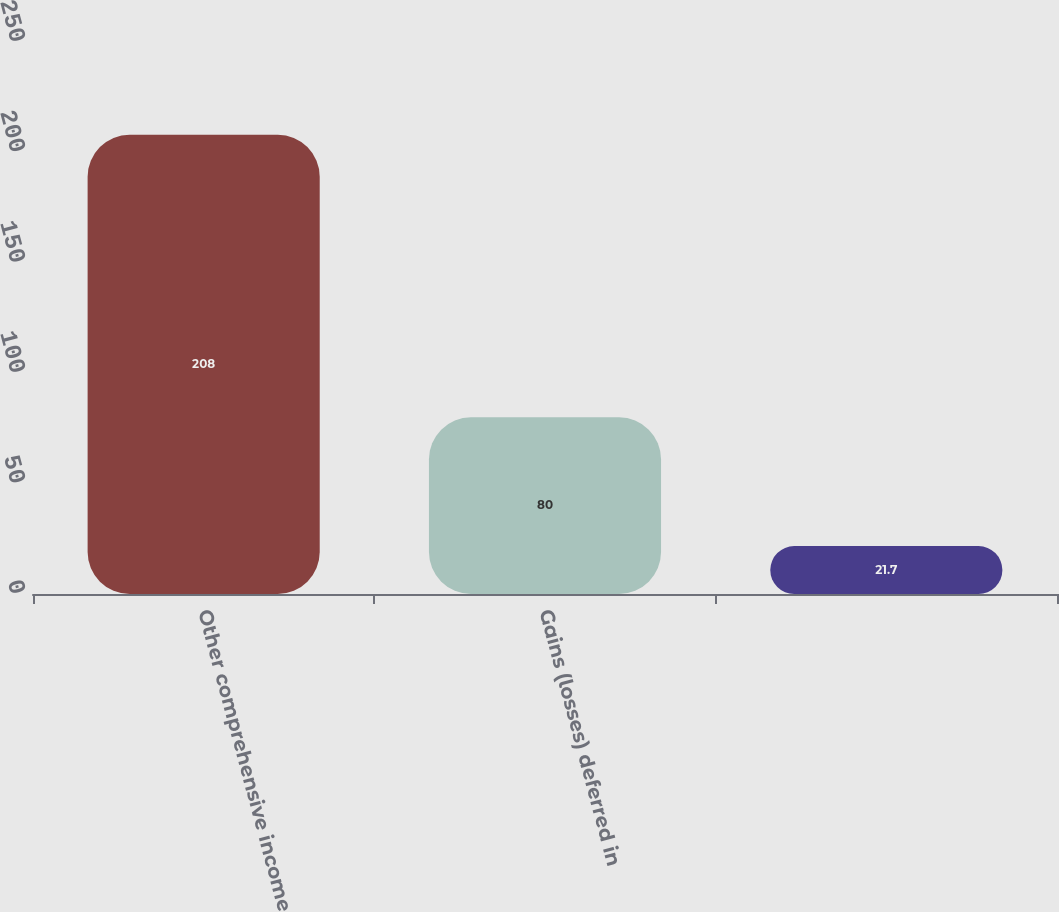Convert chart. <chart><loc_0><loc_0><loc_500><loc_500><bar_chart><fcel>Other comprehensive income<fcel>Gains (losses) deferred in<fcel>Unnamed: 2<nl><fcel>208<fcel>80<fcel>21.7<nl></chart> 